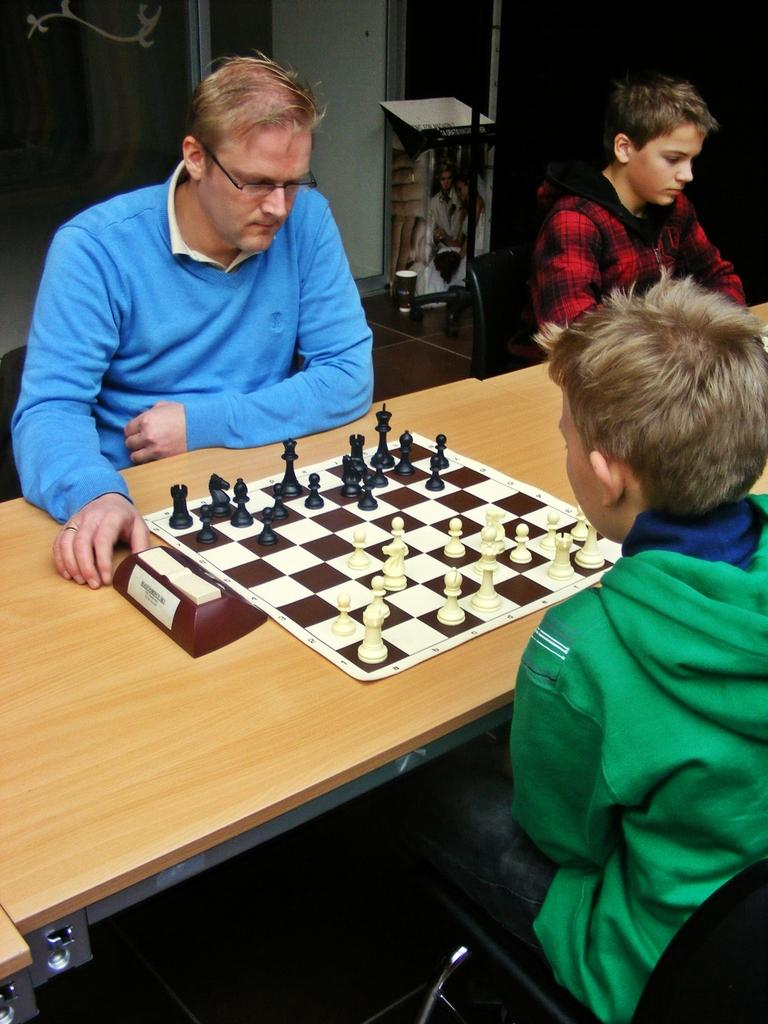Where is the kid located in the image? The kid is in the right corner of the image. What is the kid doing in the image? The kid is sitting and playing chess. Does the kid have an opponent in the game? Yes, the kid has an opponent in the game. Is there anyone else sitting near the first kid? Yes, there is another kid sitting beside the first kid. What type of sheep can be seen grazing in the background of the image? There are no sheep present in the image; it features a kid playing chess with an opponent. How does the first kid compare to the second kid in terms of chess skills? The provided facts do not offer any information about the chess skills of either kid, so it is impossible to make a comparison. 